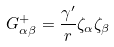<formula> <loc_0><loc_0><loc_500><loc_500>G _ { \alpha \beta } ^ { + } = \frac { \gamma ^ { \prime } } { r } \zeta _ { \alpha } \zeta _ { \beta }</formula> 